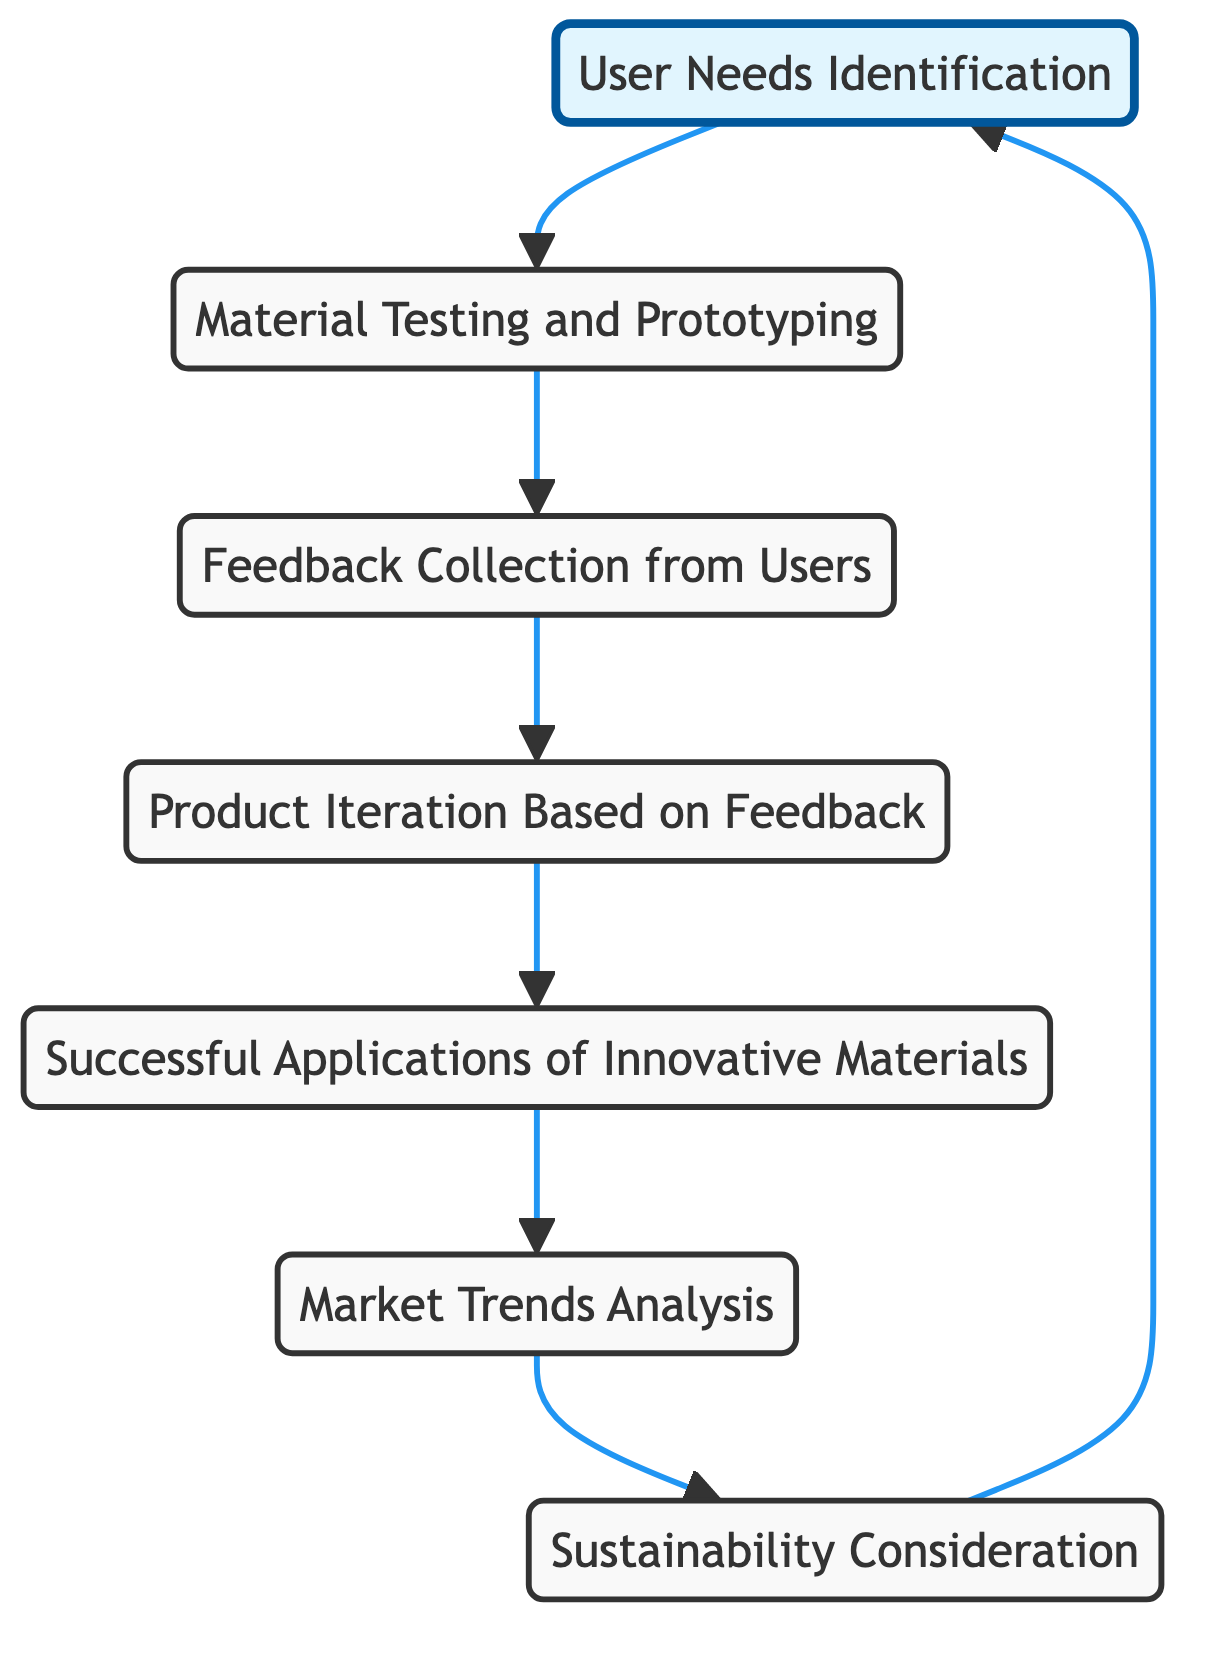What is the first step in the process represented by this diagram? The first step in the process is "User Needs Identification," which has no incoming edges and is the starting point from which the flow progresses to "Material Testing and Prototyping."
Answer: User Needs Identification How many nodes are present in the diagram? By counting the individual nodes listed in the diagram, we see there are seven: User Needs Identification, Material Testing and Prototyping, Feedback Collection from Users, Product Iteration Based on Feedback, Market Trends Analysis, Successful Applications of Innovative Materials, and Sustainability Consideration.
Answer: Seven What is the last node in the flow of the diagram? The last node in the flow is "Market Trends Analysis," which leads to the Sustainability node and completes the cycle back to User Needs Identification.
Answer: Market Trends Analysis Which node directly follows "User Needs Identification"? "Material Testing and Prototyping" follows directly after "User Needs Identification," as indicated by the directed edge in the diagram leading from User Needs to Material Testing.
Answer: Material Testing and Prototyping If feedback is collected, which process follows? The process that follows the feedback collection is "Product Iteration Based on Feedback," as shown by the directed edge leading from Feedback Collection to Product Iteration.
Answer: Product Iteration Based on Feedback What relationship exists between "Sustainability Consideration" and "Market Trends Analysis"? There is a directed edge from "Market Trends Analysis" to "Sustainability Consideration," indicating that the insights from analyzing market trends influence considerations related to sustainability.
Answer: Directed edge Which process in the diagram leads back to "User Needs Identification"? "Sustainability Consideration" leads back to "User Needs Identification," completing a feedback loop that emphasizes the importance of sustainability in understanding user needs.
Answer: Sustainability Consideration How many edges are there in total in this diagram? By counting the edges, the diagram shows a total of six edges connecting the various nodes, reflecting the directional relationships between them.
Answer: Six 